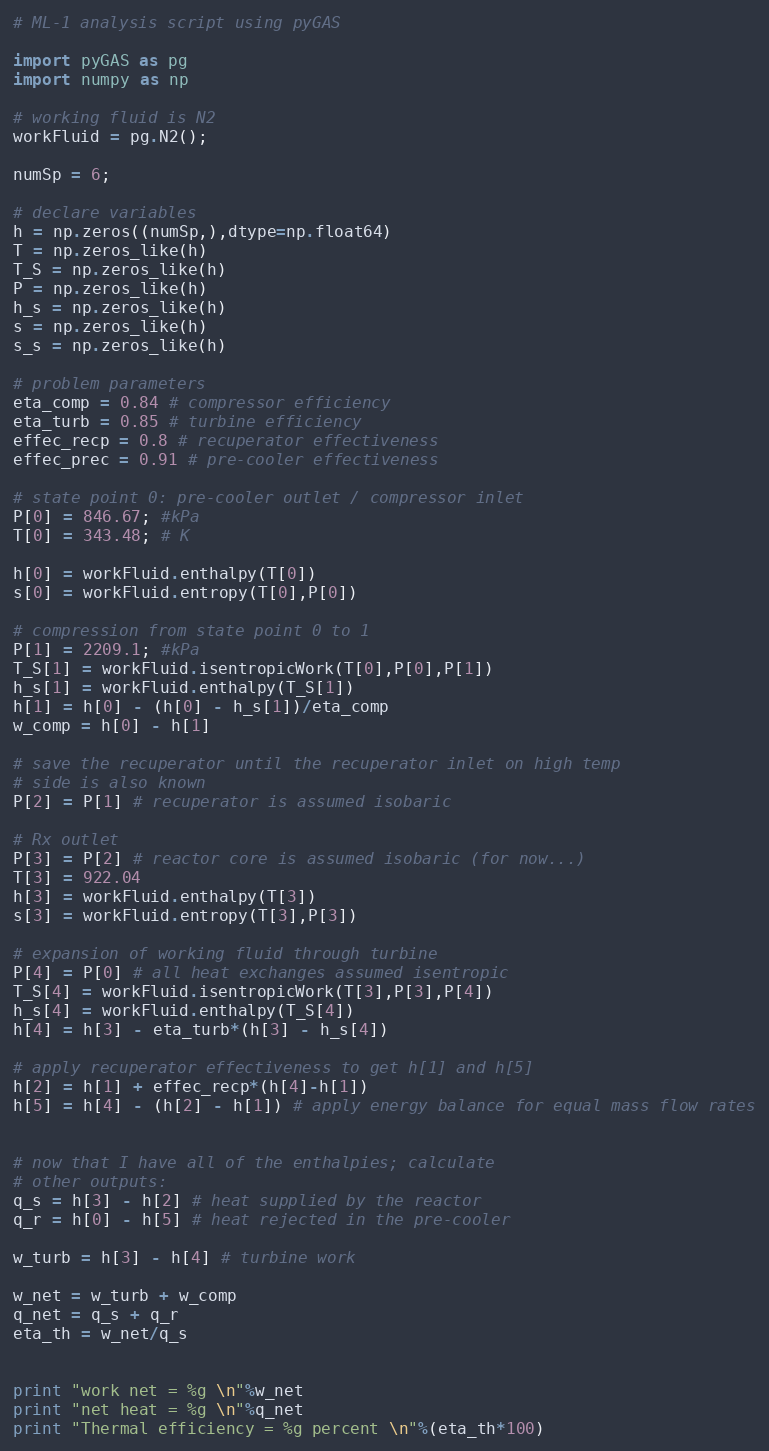Convert code to text. <code><loc_0><loc_0><loc_500><loc_500><_Python_># ML-1 analysis script using pyGAS

import pyGAS as pg
import numpy as np

# working fluid is N2
workFluid = pg.N2();

numSp = 6;

# declare variables
h = np.zeros((numSp,),dtype=np.float64)
T = np.zeros_like(h)
T_S = np.zeros_like(h)
P = np.zeros_like(h)
h_s = np.zeros_like(h)
s = np.zeros_like(h)
s_s = np.zeros_like(h)

# problem parameters
eta_comp = 0.84 # compressor efficiency
eta_turb = 0.85 # turbine efficiency
effec_recp = 0.8 # recuperator effectiveness
effec_prec = 0.91 # pre-cooler effectiveness

# state point 0: pre-cooler outlet / compressor inlet
P[0] = 846.67; #kPa
T[0] = 343.48; # K

h[0] = workFluid.enthalpy(T[0])
s[0] = workFluid.entropy(T[0],P[0])

# compression from state point 0 to 1
P[1] = 2209.1; #kPa
T_S[1] = workFluid.isentropicWork(T[0],P[0],P[1])
h_s[1] = workFluid.enthalpy(T_S[1])
h[1] = h[0] - (h[0] - h_s[1])/eta_comp
w_comp = h[0] - h[1]

# save the recuperator until the recuperator inlet on high temp
# side is also known
P[2] = P[1] # recuperator is assumed isobaric

# Rx outlet
P[3] = P[2] # reactor core is assumed isobaric (for now...)
T[3] = 922.04
h[3] = workFluid.enthalpy(T[3])
s[3] = workFluid.entropy(T[3],P[3])

# expansion of working fluid through turbine
P[4] = P[0] # all heat exchanges assumed isentropic
T_S[4] = workFluid.isentropicWork(T[3],P[3],P[4])
h_s[4] = workFluid.enthalpy(T_S[4])
h[4] = h[3] - eta_turb*(h[3] - h_s[4])

# apply recuperator effectiveness to get h[1] and h[5]
h[2] = h[1] + effec_recp*(h[4]-h[1])
h[5] = h[4] - (h[2] - h[1]) # apply energy balance for equal mass flow rates


# now that I have all of the enthalpies; calculate
# other outputs:
q_s = h[3] - h[2] # heat supplied by the reactor
q_r = h[0] - h[5] # heat rejected in the pre-cooler

w_turb = h[3] - h[4] # turbine work

w_net = w_turb + w_comp
q_net = q_s + q_r
eta_th = w_net/q_s


print "work net = %g \n"%w_net
print "net heat = %g \n"%q_net
print "Thermal efficiency = %g percent \n"%(eta_th*100)


</code> 